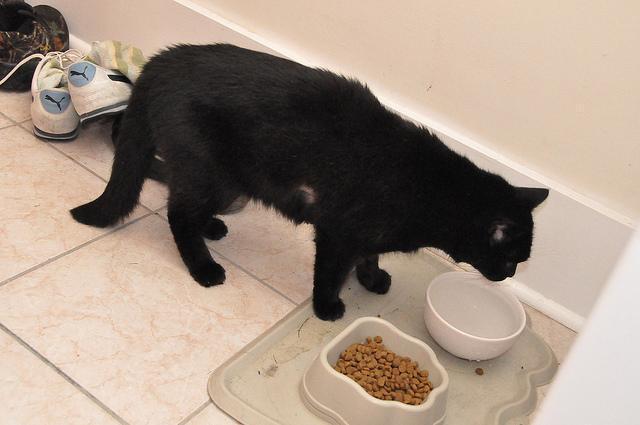How many bowls can you see?
Give a very brief answer. 2. How many orange signs are there?
Give a very brief answer. 0. 